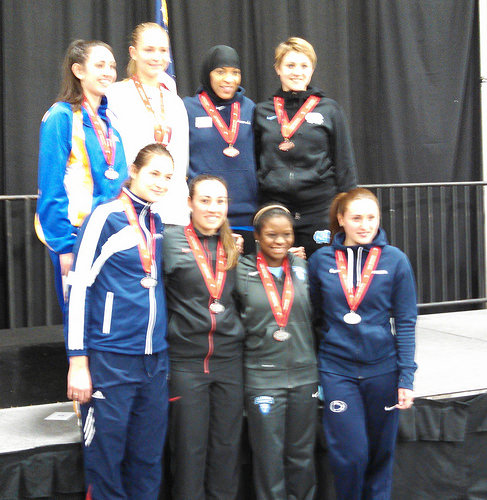<image>
Can you confirm if the fence is behind the girl? Yes. From this viewpoint, the fence is positioned behind the girl, with the girl partially or fully occluding the fence. 